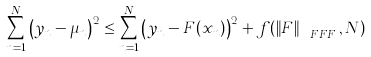<formula> <loc_0><loc_0><loc_500><loc_500>\sum _ { n = 1 } ^ { N } \left ( y _ { n } - \mu _ { n } \right ) ^ { 2 } \leq \sum _ { n = 1 } ^ { N } \left ( y _ { n } - F ( x _ { n } ) \right ) ^ { 2 } + f ( \left \| F \right \| _ { \ F F F } , N )</formula> 